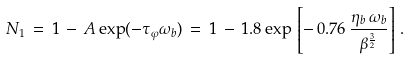<formula> <loc_0><loc_0><loc_500><loc_500>N _ { 1 } \, = \, 1 \, - \, A \exp ( - \tau _ { \varphi } \omega _ { b } ) \, = \, 1 \, - \, 1 . 8 \exp \, \left [ - \, 0 . 7 6 \, \frac { \eta _ { b } \, \omega _ { b } } { \beta ^ { \frac { 3 } { 2 } } } \right ] \, .</formula> 